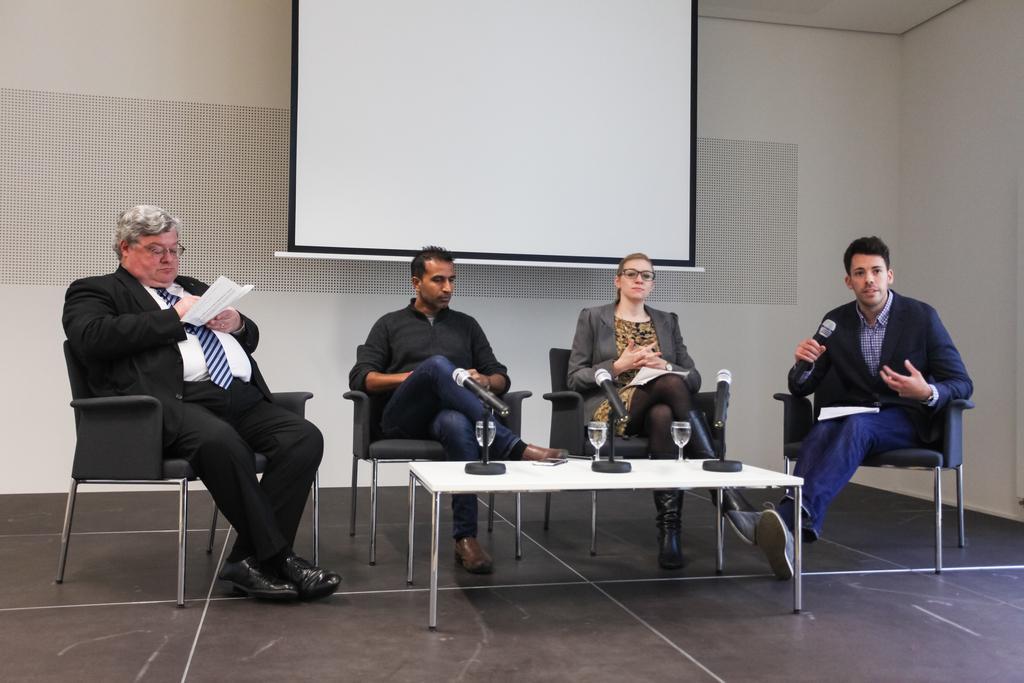In one or two sentences, can you explain what this image depicts? In this room there are group of persons who are sitting in a room on the chairs and in front of them there are microphones. 